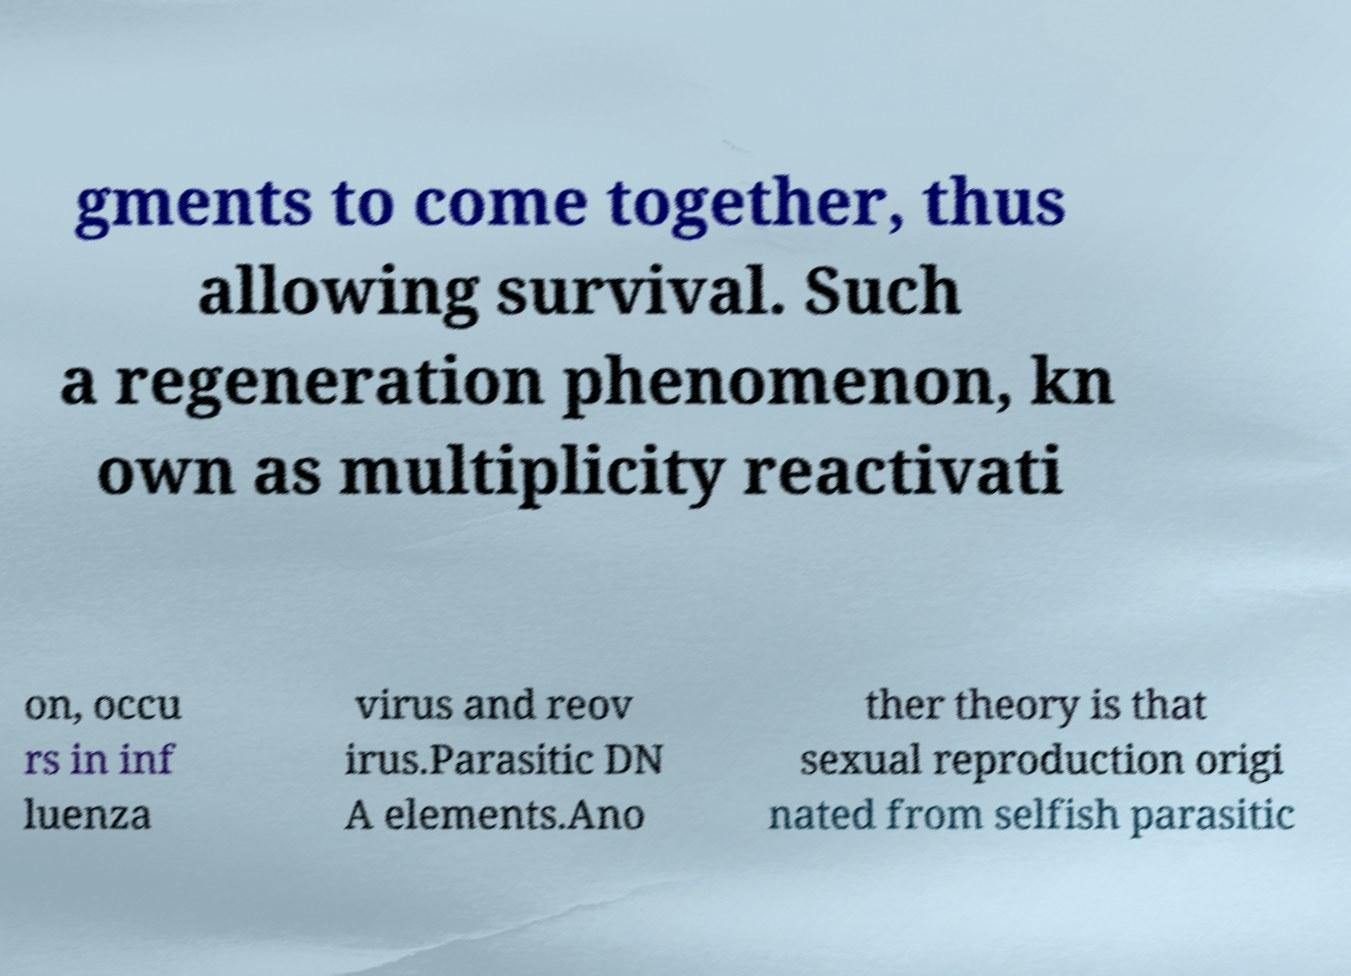Could you extract and type out the text from this image? gments to come together, thus allowing survival. Such a regeneration phenomenon, kn own as multiplicity reactivati on, occu rs in inf luenza virus and reov irus.Parasitic DN A elements.Ano ther theory is that sexual reproduction origi nated from selfish parasitic 